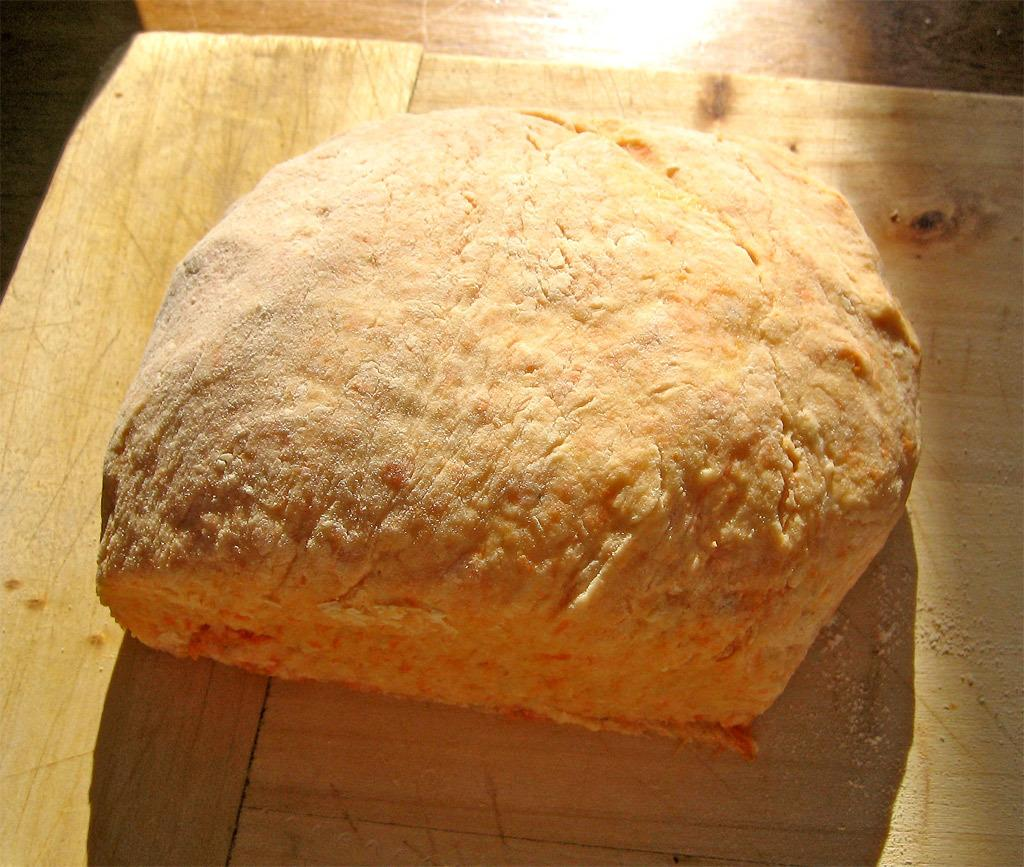What is the main object in the center of the image? There is a wooden object in the center of the image. What is placed on the wooden object? There are food items on the wooden object. What can be seen in the background of the image? There is a floor visible in the background of the image. How many dolls are playing a guitar on the wooden object in the image? There are no dolls or guitars present in the image; it features a wooden object with food items on it. 